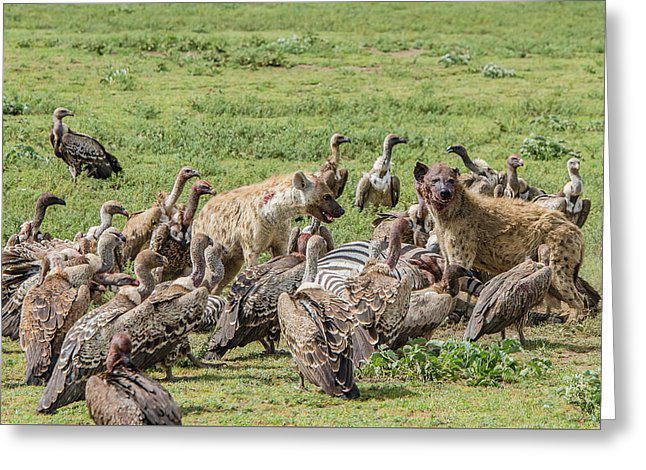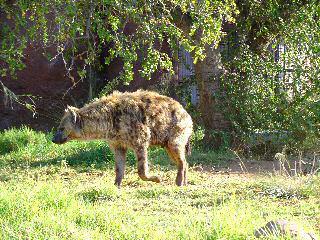The first image is the image on the left, the second image is the image on the right. Assess this claim about the two images: "In one image in the pair, the only animal that can be seen is the hyena.". Correct or not? Answer yes or no. Yes. The first image is the image on the left, the second image is the image on the right. Given the left and right images, does the statement "The left image shows at least one rear-facing hyena standing in front of two larger standing animals with horns." hold true? Answer yes or no. No. 